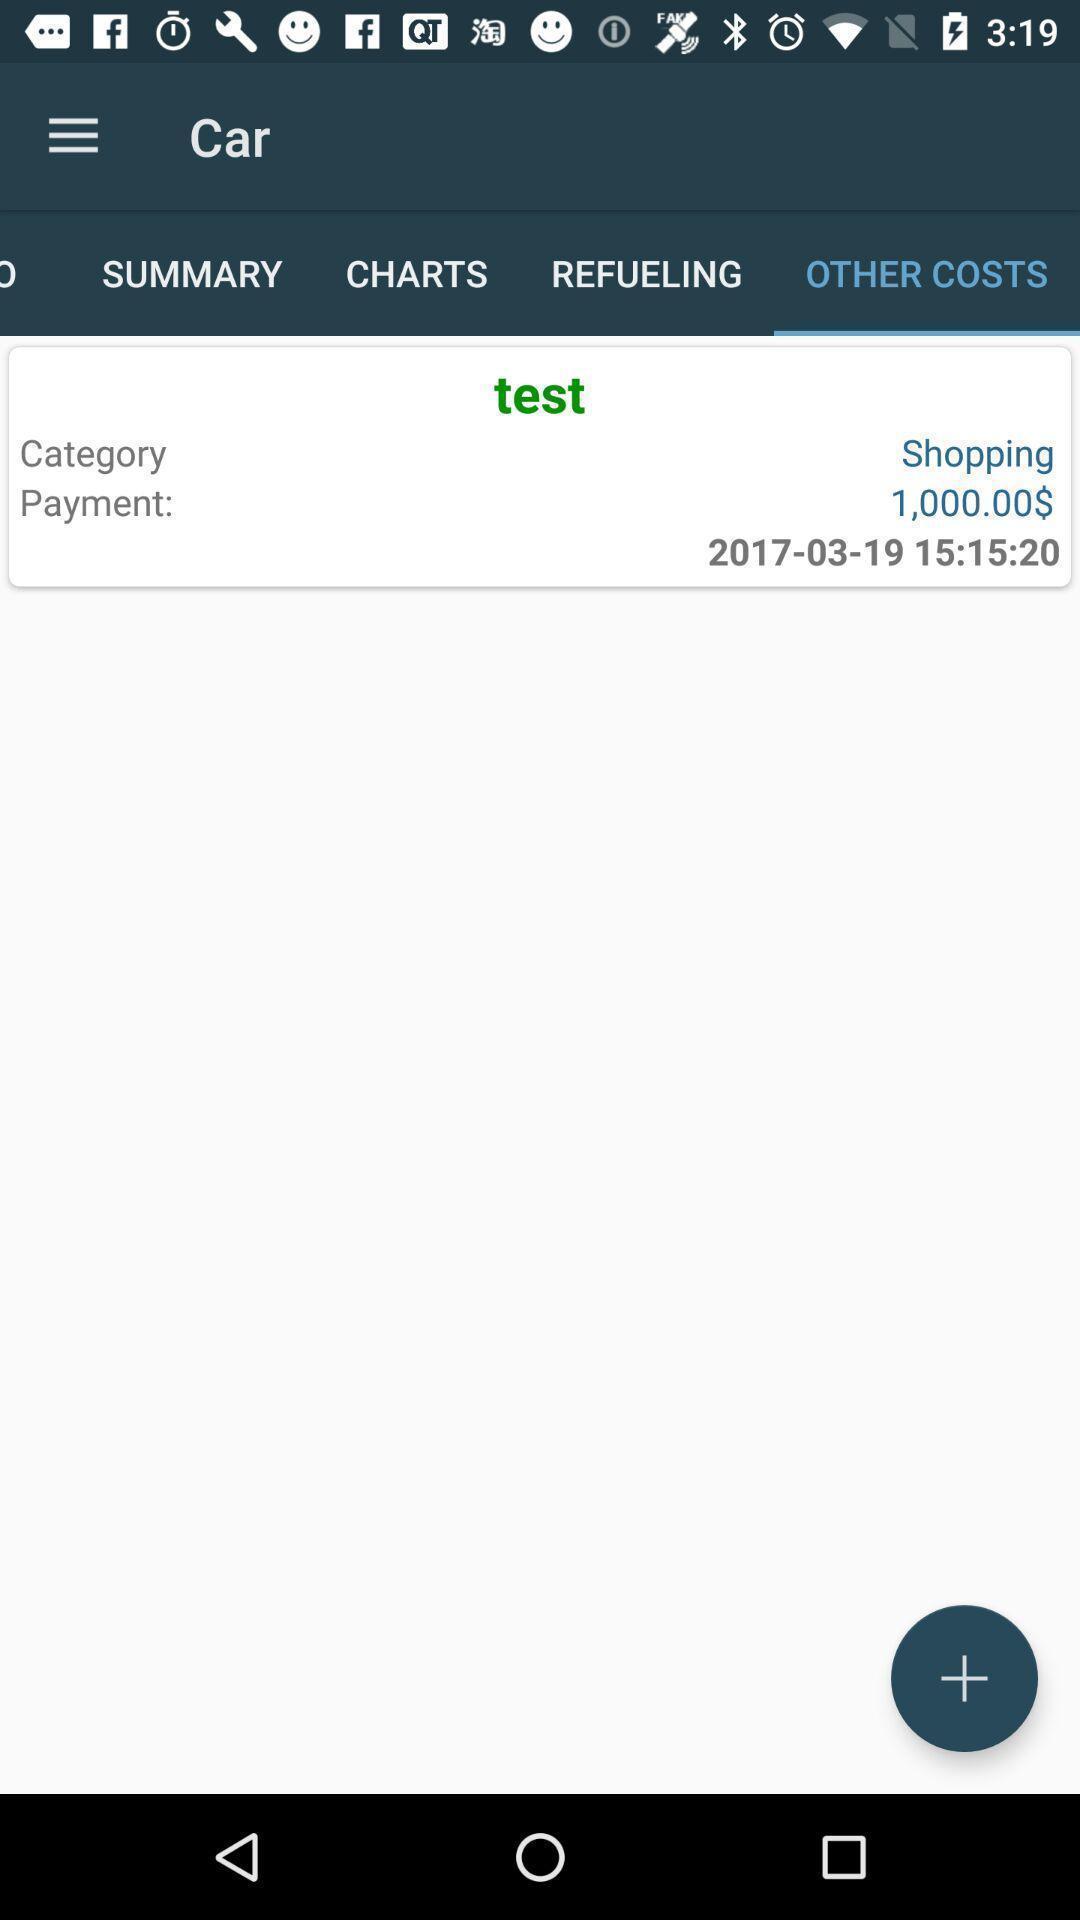Explain the elements present in this screenshot. Page showing statistics related to fuel economy. 